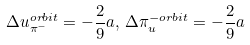<formula> <loc_0><loc_0><loc_500><loc_500>\Delta u ^ { o r b i t } _ { \pi ^ { - } } = - \frac { 2 } { 9 } a , \, \Delta \pi ^ { - o r b i t } _ { u } = - \frac { 2 } { 9 } a</formula> 